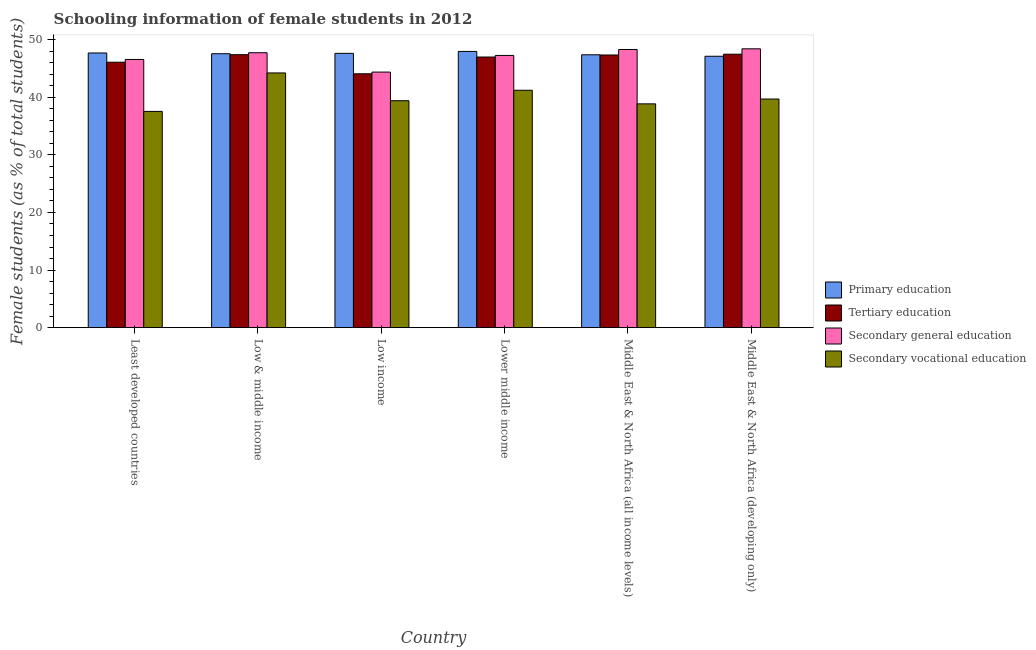How many groups of bars are there?
Your answer should be compact. 6. Are the number of bars per tick equal to the number of legend labels?
Make the answer very short. Yes. Are the number of bars on each tick of the X-axis equal?
Give a very brief answer. Yes. How many bars are there on the 5th tick from the left?
Your answer should be compact. 4. How many bars are there on the 1st tick from the right?
Offer a very short reply. 4. What is the label of the 6th group of bars from the left?
Your answer should be compact. Middle East & North Africa (developing only). What is the percentage of female students in primary education in Middle East & North Africa (developing only)?
Offer a very short reply. 47.12. Across all countries, what is the maximum percentage of female students in primary education?
Your answer should be very brief. 47.95. Across all countries, what is the minimum percentage of female students in tertiary education?
Offer a terse response. 44.07. In which country was the percentage of female students in primary education maximum?
Offer a very short reply. Lower middle income. What is the total percentage of female students in secondary vocational education in the graph?
Provide a short and direct response. 240.92. What is the difference between the percentage of female students in primary education in Least developed countries and that in Lower middle income?
Provide a short and direct response. -0.27. What is the difference between the percentage of female students in secondary vocational education in Lower middle income and the percentage of female students in tertiary education in Middle East & North Africa (developing only)?
Ensure brevity in your answer.  -6.26. What is the average percentage of female students in primary education per country?
Your response must be concise. 47.55. What is the difference between the percentage of female students in primary education and percentage of female students in tertiary education in Low & middle income?
Ensure brevity in your answer.  0.16. What is the ratio of the percentage of female students in secondary vocational education in Least developed countries to that in Low income?
Keep it short and to the point. 0.95. What is the difference between the highest and the second highest percentage of female students in secondary vocational education?
Provide a short and direct response. 3.01. What is the difference between the highest and the lowest percentage of female students in tertiary education?
Your response must be concise. 3.4. In how many countries, is the percentage of female students in tertiary education greater than the average percentage of female students in tertiary education taken over all countries?
Your answer should be very brief. 4. Is the sum of the percentage of female students in tertiary education in Lower middle income and Middle East & North Africa (developing only) greater than the maximum percentage of female students in secondary education across all countries?
Your answer should be very brief. Yes. What does the 1st bar from the left in Lower middle income represents?
Offer a terse response. Primary education. What does the 2nd bar from the right in Middle East & North Africa (developing only) represents?
Your answer should be very brief. Secondary general education. Is it the case that in every country, the sum of the percentage of female students in primary education and percentage of female students in tertiary education is greater than the percentage of female students in secondary education?
Your answer should be very brief. Yes. What is the difference between two consecutive major ticks on the Y-axis?
Your answer should be very brief. 10. Does the graph contain any zero values?
Your response must be concise. No. How many legend labels are there?
Keep it short and to the point. 4. How are the legend labels stacked?
Provide a succinct answer. Vertical. What is the title of the graph?
Provide a short and direct response. Schooling information of female students in 2012. What is the label or title of the X-axis?
Ensure brevity in your answer.  Country. What is the label or title of the Y-axis?
Make the answer very short. Female students (as % of total students). What is the Female students (as % of total students) in Primary education in Least developed countries?
Offer a terse response. 47.69. What is the Female students (as % of total students) in Tertiary education in Least developed countries?
Give a very brief answer. 46.08. What is the Female students (as % of total students) of Secondary general education in Least developed countries?
Your response must be concise. 46.56. What is the Female students (as % of total students) of Secondary vocational education in Least developed countries?
Ensure brevity in your answer.  37.54. What is the Female students (as % of total students) in Primary education in Low & middle income?
Ensure brevity in your answer.  47.56. What is the Female students (as % of total students) of Tertiary education in Low & middle income?
Make the answer very short. 47.39. What is the Female students (as % of total students) of Secondary general education in Low & middle income?
Keep it short and to the point. 47.73. What is the Female students (as % of total students) in Secondary vocational education in Low & middle income?
Make the answer very short. 44.22. What is the Female students (as % of total students) of Primary education in Low income?
Your response must be concise. 47.62. What is the Female students (as % of total students) of Tertiary education in Low income?
Keep it short and to the point. 44.07. What is the Female students (as % of total students) of Secondary general education in Low income?
Offer a terse response. 44.37. What is the Female students (as % of total students) of Secondary vocational education in Low income?
Provide a short and direct response. 39.4. What is the Female students (as % of total students) of Primary education in Lower middle income?
Offer a terse response. 47.95. What is the Female students (as % of total students) of Tertiary education in Lower middle income?
Offer a terse response. 46.98. What is the Female students (as % of total students) in Secondary general education in Lower middle income?
Ensure brevity in your answer.  47.26. What is the Female students (as % of total students) in Secondary vocational education in Lower middle income?
Give a very brief answer. 41.21. What is the Female students (as % of total students) of Primary education in Middle East & North Africa (all income levels)?
Give a very brief answer. 47.37. What is the Female students (as % of total students) of Tertiary education in Middle East & North Africa (all income levels)?
Provide a short and direct response. 47.34. What is the Female students (as % of total students) in Secondary general education in Middle East & North Africa (all income levels)?
Offer a very short reply. 48.29. What is the Female students (as % of total students) in Secondary vocational education in Middle East & North Africa (all income levels)?
Give a very brief answer. 38.85. What is the Female students (as % of total students) of Primary education in Middle East & North Africa (developing only)?
Offer a terse response. 47.12. What is the Female students (as % of total students) of Tertiary education in Middle East & North Africa (developing only)?
Give a very brief answer. 47.47. What is the Female students (as % of total students) in Secondary general education in Middle East & North Africa (developing only)?
Make the answer very short. 48.41. What is the Female students (as % of total students) of Secondary vocational education in Middle East & North Africa (developing only)?
Keep it short and to the point. 39.69. Across all countries, what is the maximum Female students (as % of total students) of Primary education?
Provide a short and direct response. 47.95. Across all countries, what is the maximum Female students (as % of total students) in Tertiary education?
Keep it short and to the point. 47.47. Across all countries, what is the maximum Female students (as % of total students) in Secondary general education?
Your answer should be very brief. 48.41. Across all countries, what is the maximum Female students (as % of total students) in Secondary vocational education?
Offer a terse response. 44.22. Across all countries, what is the minimum Female students (as % of total students) of Primary education?
Make the answer very short. 47.12. Across all countries, what is the minimum Female students (as % of total students) in Tertiary education?
Your answer should be very brief. 44.07. Across all countries, what is the minimum Female students (as % of total students) in Secondary general education?
Provide a short and direct response. 44.37. Across all countries, what is the minimum Female students (as % of total students) of Secondary vocational education?
Your response must be concise. 37.54. What is the total Female students (as % of total students) of Primary education in the graph?
Offer a terse response. 285.3. What is the total Female students (as % of total students) of Tertiary education in the graph?
Offer a terse response. 279.33. What is the total Female students (as % of total students) of Secondary general education in the graph?
Provide a short and direct response. 282.61. What is the total Female students (as % of total students) of Secondary vocational education in the graph?
Ensure brevity in your answer.  240.92. What is the difference between the Female students (as % of total students) of Primary education in Least developed countries and that in Low & middle income?
Offer a terse response. 0.13. What is the difference between the Female students (as % of total students) of Tertiary education in Least developed countries and that in Low & middle income?
Provide a succinct answer. -1.31. What is the difference between the Female students (as % of total students) in Secondary general education in Least developed countries and that in Low & middle income?
Give a very brief answer. -1.17. What is the difference between the Female students (as % of total students) of Secondary vocational education in Least developed countries and that in Low & middle income?
Make the answer very short. -6.68. What is the difference between the Female students (as % of total students) of Primary education in Least developed countries and that in Low income?
Your response must be concise. 0.06. What is the difference between the Female students (as % of total students) of Tertiary education in Least developed countries and that in Low income?
Provide a succinct answer. 2.01. What is the difference between the Female students (as % of total students) of Secondary general education in Least developed countries and that in Low income?
Offer a very short reply. 2.19. What is the difference between the Female students (as % of total students) in Secondary vocational education in Least developed countries and that in Low income?
Provide a succinct answer. -1.86. What is the difference between the Female students (as % of total students) of Primary education in Least developed countries and that in Lower middle income?
Ensure brevity in your answer.  -0.27. What is the difference between the Female students (as % of total students) of Tertiary education in Least developed countries and that in Lower middle income?
Your answer should be compact. -0.91. What is the difference between the Female students (as % of total students) in Secondary general education in Least developed countries and that in Lower middle income?
Your answer should be compact. -0.7. What is the difference between the Female students (as % of total students) of Secondary vocational education in Least developed countries and that in Lower middle income?
Make the answer very short. -3.67. What is the difference between the Female students (as % of total students) of Primary education in Least developed countries and that in Middle East & North Africa (all income levels)?
Ensure brevity in your answer.  0.31. What is the difference between the Female students (as % of total students) in Tertiary education in Least developed countries and that in Middle East & North Africa (all income levels)?
Provide a succinct answer. -1.26. What is the difference between the Female students (as % of total students) in Secondary general education in Least developed countries and that in Middle East & North Africa (all income levels)?
Make the answer very short. -1.73. What is the difference between the Female students (as % of total students) in Secondary vocational education in Least developed countries and that in Middle East & North Africa (all income levels)?
Offer a very short reply. -1.31. What is the difference between the Female students (as % of total students) of Primary education in Least developed countries and that in Middle East & North Africa (developing only)?
Provide a short and direct response. 0.57. What is the difference between the Female students (as % of total students) of Tertiary education in Least developed countries and that in Middle East & North Africa (developing only)?
Provide a short and direct response. -1.39. What is the difference between the Female students (as % of total students) in Secondary general education in Least developed countries and that in Middle East & North Africa (developing only)?
Keep it short and to the point. -1.85. What is the difference between the Female students (as % of total students) of Secondary vocational education in Least developed countries and that in Middle East & North Africa (developing only)?
Offer a terse response. -2.15. What is the difference between the Female students (as % of total students) in Primary education in Low & middle income and that in Low income?
Provide a succinct answer. -0.07. What is the difference between the Female students (as % of total students) of Tertiary education in Low & middle income and that in Low income?
Your answer should be compact. 3.32. What is the difference between the Female students (as % of total students) in Secondary general education in Low & middle income and that in Low income?
Your answer should be compact. 3.36. What is the difference between the Female students (as % of total students) in Secondary vocational education in Low & middle income and that in Low income?
Your response must be concise. 4.82. What is the difference between the Female students (as % of total students) of Primary education in Low & middle income and that in Lower middle income?
Give a very brief answer. -0.4. What is the difference between the Female students (as % of total students) in Tertiary education in Low & middle income and that in Lower middle income?
Your response must be concise. 0.41. What is the difference between the Female students (as % of total students) of Secondary general education in Low & middle income and that in Lower middle income?
Keep it short and to the point. 0.47. What is the difference between the Female students (as % of total students) in Secondary vocational education in Low & middle income and that in Lower middle income?
Offer a terse response. 3.01. What is the difference between the Female students (as % of total students) of Primary education in Low & middle income and that in Middle East & North Africa (all income levels)?
Keep it short and to the point. 0.18. What is the difference between the Female students (as % of total students) of Tertiary education in Low & middle income and that in Middle East & North Africa (all income levels)?
Your answer should be very brief. 0.05. What is the difference between the Female students (as % of total students) in Secondary general education in Low & middle income and that in Middle East & North Africa (all income levels)?
Your response must be concise. -0.56. What is the difference between the Female students (as % of total students) in Secondary vocational education in Low & middle income and that in Middle East & North Africa (all income levels)?
Ensure brevity in your answer.  5.37. What is the difference between the Female students (as % of total students) in Primary education in Low & middle income and that in Middle East & North Africa (developing only)?
Ensure brevity in your answer.  0.44. What is the difference between the Female students (as % of total students) in Tertiary education in Low & middle income and that in Middle East & North Africa (developing only)?
Keep it short and to the point. -0.08. What is the difference between the Female students (as % of total students) in Secondary general education in Low & middle income and that in Middle East & North Africa (developing only)?
Provide a succinct answer. -0.68. What is the difference between the Female students (as % of total students) of Secondary vocational education in Low & middle income and that in Middle East & North Africa (developing only)?
Offer a terse response. 4.53. What is the difference between the Female students (as % of total students) in Primary education in Low income and that in Lower middle income?
Your response must be concise. -0.33. What is the difference between the Female students (as % of total students) of Tertiary education in Low income and that in Lower middle income?
Give a very brief answer. -2.91. What is the difference between the Female students (as % of total students) in Secondary general education in Low income and that in Lower middle income?
Your answer should be compact. -2.89. What is the difference between the Female students (as % of total students) of Secondary vocational education in Low income and that in Lower middle income?
Offer a very short reply. -1.81. What is the difference between the Female students (as % of total students) of Primary education in Low income and that in Middle East & North Africa (all income levels)?
Keep it short and to the point. 0.25. What is the difference between the Female students (as % of total students) of Tertiary education in Low income and that in Middle East & North Africa (all income levels)?
Your answer should be very brief. -3.26. What is the difference between the Female students (as % of total students) in Secondary general education in Low income and that in Middle East & North Africa (all income levels)?
Your answer should be compact. -3.92. What is the difference between the Female students (as % of total students) in Secondary vocational education in Low income and that in Middle East & North Africa (all income levels)?
Offer a very short reply. 0.55. What is the difference between the Female students (as % of total students) of Primary education in Low income and that in Middle East & North Africa (developing only)?
Your answer should be compact. 0.51. What is the difference between the Female students (as % of total students) in Tertiary education in Low income and that in Middle East & North Africa (developing only)?
Provide a short and direct response. -3.4. What is the difference between the Female students (as % of total students) in Secondary general education in Low income and that in Middle East & North Africa (developing only)?
Offer a terse response. -4.04. What is the difference between the Female students (as % of total students) of Secondary vocational education in Low income and that in Middle East & North Africa (developing only)?
Your response must be concise. -0.29. What is the difference between the Female students (as % of total students) of Primary education in Lower middle income and that in Middle East & North Africa (all income levels)?
Ensure brevity in your answer.  0.58. What is the difference between the Female students (as % of total students) of Tertiary education in Lower middle income and that in Middle East & North Africa (all income levels)?
Your response must be concise. -0.35. What is the difference between the Female students (as % of total students) of Secondary general education in Lower middle income and that in Middle East & North Africa (all income levels)?
Your answer should be very brief. -1.03. What is the difference between the Female students (as % of total students) in Secondary vocational education in Lower middle income and that in Middle East & North Africa (all income levels)?
Your answer should be very brief. 2.36. What is the difference between the Female students (as % of total students) in Primary education in Lower middle income and that in Middle East & North Africa (developing only)?
Provide a succinct answer. 0.84. What is the difference between the Female students (as % of total students) in Tertiary education in Lower middle income and that in Middle East & North Africa (developing only)?
Your answer should be compact. -0.49. What is the difference between the Female students (as % of total students) in Secondary general education in Lower middle income and that in Middle East & North Africa (developing only)?
Your response must be concise. -1.15. What is the difference between the Female students (as % of total students) in Secondary vocational education in Lower middle income and that in Middle East & North Africa (developing only)?
Your answer should be very brief. 1.52. What is the difference between the Female students (as % of total students) in Primary education in Middle East & North Africa (all income levels) and that in Middle East & North Africa (developing only)?
Make the answer very short. 0.25. What is the difference between the Female students (as % of total students) in Tertiary education in Middle East & North Africa (all income levels) and that in Middle East & North Africa (developing only)?
Provide a succinct answer. -0.14. What is the difference between the Female students (as % of total students) in Secondary general education in Middle East & North Africa (all income levels) and that in Middle East & North Africa (developing only)?
Offer a terse response. -0.12. What is the difference between the Female students (as % of total students) of Secondary vocational education in Middle East & North Africa (all income levels) and that in Middle East & North Africa (developing only)?
Your answer should be very brief. -0.84. What is the difference between the Female students (as % of total students) in Primary education in Least developed countries and the Female students (as % of total students) in Tertiary education in Low & middle income?
Keep it short and to the point. 0.29. What is the difference between the Female students (as % of total students) of Primary education in Least developed countries and the Female students (as % of total students) of Secondary general education in Low & middle income?
Provide a succinct answer. -0.04. What is the difference between the Female students (as % of total students) in Primary education in Least developed countries and the Female students (as % of total students) in Secondary vocational education in Low & middle income?
Offer a terse response. 3.47. What is the difference between the Female students (as % of total students) in Tertiary education in Least developed countries and the Female students (as % of total students) in Secondary general education in Low & middle income?
Your answer should be compact. -1.65. What is the difference between the Female students (as % of total students) in Tertiary education in Least developed countries and the Female students (as % of total students) in Secondary vocational education in Low & middle income?
Offer a very short reply. 1.86. What is the difference between the Female students (as % of total students) of Secondary general education in Least developed countries and the Female students (as % of total students) of Secondary vocational education in Low & middle income?
Make the answer very short. 2.34. What is the difference between the Female students (as % of total students) in Primary education in Least developed countries and the Female students (as % of total students) in Tertiary education in Low income?
Your answer should be very brief. 3.61. What is the difference between the Female students (as % of total students) of Primary education in Least developed countries and the Female students (as % of total students) of Secondary general education in Low income?
Your answer should be compact. 3.32. What is the difference between the Female students (as % of total students) of Primary education in Least developed countries and the Female students (as % of total students) of Secondary vocational education in Low income?
Give a very brief answer. 8.29. What is the difference between the Female students (as % of total students) of Tertiary education in Least developed countries and the Female students (as % of total students) of Secondary general education in Low income?
Give a very brief answer. 1.71. What is the difference between the Female students (as % of total students) of Tertiary education in Least developed countries and the Female students (as % of total students) of Secondary vocational education in Low income?
Offer a very short reply. 6.68. What is the difference between the Female students (as % of total students) of Secondary general education in Least developed countries and the Female students (as % of total students) of Secondary vocational education in Low income?
Provide a short and direct response. 7.16. What is the difference between the Female students (as % of total students) of Primary education in Least developed countries and the Female students (as % of total students) of Tertiary education in Lower middle income?
Ensure brevity in your answer.  0.7. What is the difference between the Female students (as % of total students) of Primary education in Least developed countries and the Female students (as % of total students) of Secondary general education in Lower middle income?
Provide a short and direct response. 0.43. What is the difference between the Female students (as % of total students) of Primary education in Least developed countries and the Female students (as % of total students) of Secondary vocational education in Lower middle income?
Your answer should be very brief. 6.47. What is the difference between the Female students (as % of total students) in Tertiary education in Least developed countries and the Female students (as % of total students) in Secondary general education in Lower middle income?
Your answer should be very brief. -1.18. What is the difference between the Female students (as % of total students) of Tertiary education in Least developed countries and the Female students (as % of total students) of Secondary vocational education in Lower middle income?
Provide a short and direct response. 4.87. What is the difference between the Female students (as % of total students) in Secondary general education in Least developed countries and the Female students (as % of total students) in Secondary vocational education in Lower middle income?
Give a very brief answer. 5.35. What is the difference between the Female students (as % of total students) in Primary education in Least developed countries and the Female students (as % of total students) in Tertiary education in Middle East & North Africa (all income levels)?
Your response must be concise. 0.35. What is the difference between the Female students (as % of total students) of Primary education in Least developed countries and the Female students (as % of total students) of Secondary general education in Middle East & North Africa (all income levels)?
Your answer should be very brief. -0.61. What is the difference between the Female students (as % of total students) of Primary education in Least developed countries and the Female students (as % of total students) of Secondary vocational education in Middle East & North Africa (all income levels)?
Make the answer very short. 8.83. What is the difference between the Female students (as % of total students) of Tertiary education in Least developed countries and the Female students (as % of total students) of Secondary general education in Middle East & North Africa (all income levels)?
Make the answer very short. -2.21. What is the difference between the Female students (as % of total students) in Tertiary education in Least developed countries and the Female students (as % of total students) in Secondary vocational education in Middle East & North Africa (all income levels)?
Keep it short and to the point. 7.23. What is the difference between the Female students (as % of total students) in Secondary general education in Least developed countries and the Female students (as % of total students) in Secondary vocational education in Middle East & North Africa (all income levels)?
Make the answer very short. 7.71. What is the difference between the Female students (as % of total students) in Primary education in Least developed countries and the Female students (as % of total students) in Tertiary education in Middle East & North Africa (developing only)?
Ensure brevity in your answer.  0.21. What is the difference between the Female students (as % of total students) in Primary education in Least developed countries and the Female students (as % of total students) in Secondary general education in Middle East & North Africa (developing only)?
Ensure brevity in your answer.  -0.72. What is the difference between the Female students (as % of total students) in Primary education in Least developed countries and the Female students (as % of total students) in Secondary vocational education in Middle East & North Africa (developing only)?
Ensure brevity in your answer.  7.99. What is the difference between the Female students (as % of total students) in Tertiary education in Least developed countries and the Female students (as % of total students) in Secondary general education in Middle East & North Africa (developing only)?
Offer a terse response. -2.33. What is the difference between the Female students (as % of total students) of Tertiary education in Least developed countries and the Female students (as % of total students) of Secondary vocational education in Middle East & North Africa (developing only)?
Your answer should be very brief. 6.39. What is the difference between the Female students (as % of total students) in Secondary general education in Least developed countries and the Female students (as % of total students) in Secondary vocational education in Middle East & North Africa (developing only)?
Keep it short and to the point. 6.87. What is the difference between the Female students (as % of total students) of Primary education in Low & middle income and the Female students (as % of total students) of Tertiary education in Low income?
Your response must be concise. 3.48. What is the difference between the Female students (as % of total students) in Primary education in Low & middle income and the Female students (as % of total students) in Secondary general education in Low income?
Make the answer very short. 3.19. What is the difference between the Female students (as % of total students) in Primary education in Low & middle income and the Female students (as % of total students) in Secondary vocational education in Low income?
Offer a very short reply. 8.16. What is the difference between the Female students (as % of total students) in Tertiary education in Low & middle income and the Female students (as % of total students) in Secondary general education in Low income?
Provide a short and direct response. 3.02. What is the difference between the Female students (as % of total students) in Tertiary education in Low & middle income and the Female students (as % of total students) in Secondary vocational education in Low income?
Give a very brief answer. 7.99. What is the difference between the Female students (as % of total students) in Secondary general education in Low & middle income and the Female students (as % of total students) in Secondary vocational education in Low income?
Offer a terse response. 8.33. What is the difference between the Female students (as % of total students) in Primary education in Low & middle income and the Female students (as % of total students) in Tertiary education in Lower middle income?
Keep it short and to the point. 0.57. What is the difference between the Female students (as % of total students) in Primary education in Low & middle income and the Female students (as % of total students) in Secondary general education in Lower middle income?
Offer a terse response. 0.3. What is the difference between the Female students (as % of total students) of Primary education in Low & middle income and the Female students (as % of total students) of Secondary vocational education in Lower middle income?
Make the answer very short. 6.34. What is the difference between the Female students (as % of total students) of Tertiary education in Low & middle income and the Female students (as % of total students) of Secondary general education in Lower middle income?
Keep it short and to the point. 0.13. What is the difference between the Female students (as % of total students) of Tertiary education in Low & middle income and the Female students (as % of total students) of Secondary vocational education in Lower middle income?
Your answer should be compact. 6.18. What is the difference between the Female students (as % of total students) of Secondary general education in Low & middle income and the Female students (as % of total students) of Secondary vocational education in Lower middle income?
Offer a very short reply. 6.52. What is the difference between the Female students (as % of total students) of Primary education in Low & middle income and the Female students (as % of total students) of Tertiary education in Middle East & North Africa (all income levels)?
Make the answer very short. 0.22. What is the difference between the Female students (as % of total students) of Primary education in Low & middle income and the Female students (as % of total students) of Secondary general education in Middle East & North Africa (all income levels)?
Your answer should be compact. -0.74. What is the difference between the Female students (as % of total students) of Primary education in Low & middle income and the Female students (as % of total students) of Secondary vocational education in Middle East & North Africa (all income levels)?
Provide a short and direct response. 8.7. What is the difference between the Female students (as % of total students) in Tertiary education in Low & middle income and the Female students (as % of total students) in Secondary general education in Middle East & North Africa (all income levels)?
Keep it short and to the point. -0.9. What is the difference between the Female students (as % of total students) in Tertiary education in Low & middle income and the Female students (as % of total students) in Secondary vocational education in Middle East & North Africa (all income levels)?
Make the answer very short. 8.54. What is the difference between the Female students (as % of total students) in Secondary general education in Low & middle income and the Female students (as % of total students) in Secondary vocational education in Middle East & North Africa (all income levels)?
Ensure brevity in your answer.  8.88. What is the difference between the Female students (as % of total students) of Primary education in Low & middle income and the Female students (as % of total students) of Tertiary education in Middle East & North Africa (developing only)?
Your answer should be very brief. 0.08. What is the difference between the Female students (as % of total students) of Primary education in Low & middle income and the Female students (as % of total students) of Secondary general education in Middle East & North Africa (developing only)?
Offer a terse response. -0.85. What is the difference between the Female students (as % of total students) of Primary education in Low & middle income and the Female students (as % of total students) of Secondary vocational education in Middle East & North Africa (developing only)?
Offer a terse response. 7.86. What is the difference between the Female students (as % of total students) of Tertiary education in Low & middle income and the Female students (as % of total students) of Secondary general education in Middle East & North Africa (developing only)?
Ensure brevity in your answer.  -1.02. What is the difference between the Female students (as % of total students) of Tertiary education in Low & middle income and the Female students (as % of total students) of Secondary vocational education in Middle East & North Africa (developing only)?
Ensure brevity in your answer.  7.7. What is the difference between the Female students (as % of total students) in Secondary general education in Low & middle income and the Female students (as % of total students) in Secondary vocational education in Middle East & North Africa (developing only)?
Give a very brief answer. 8.04. What is the difference between the Female students (as % of total students) in Primary education in Low income and the Female students (as % of total students) in Tertiary education in Lower middle income?
Keep it short and to the point. 0.64. What is the difference between the Female students (as % of total students) in Primary education in Low income and the Female students (as % of total students) in Secondary general education in Lower middle income?
Your response must be concise. 0.36. What is the difference between the Female students (as % of total students) in Primary education in Low income and the Female students (as % of total students) in Secondary vocational education in Lower middle income?
Make the answer very short. 6.41. What is the difference between the Female students (as % of total students) of Tertiary education in Low income and the Female students (as % of total students) of Secondary general education in Lower middle income?
Your answer should be compact. -3.19. What is the difference between the Female students (as % of total students) in Tertiary education in Low income and the Female students (as % of total students) in Secondary vocational education in Lower middle income?
Offer a very short reply. 2.86. What is the difference between the Female students (as % of total students) of Secondary general education in Low income and the Female students (as % of total students) of Secondary vocational education in Lower middle income?
Your response must be concise. 3.15. What is the difference between the Female students (as % of total students) of Primary education in Low income and the Female students (as % of total students) of Tertiary education in Middle East & North Africa (all income levels)?
Offer a very short reply. 0.29. What is the difference between the Female students (as % of total students) in Primary education in Low income and the Female students (as % of total students) in Secondary general education in Middle East & North Africa (all income levels)?
Provide a short and direct response. -0.67. What is the difference between the Female students (as % of total students) of Primary education in Low income and the Female students (as % of total students) of Secondary vocational education in Middle East & North Africa (all income levels)?
Your answer should be compact. 8.77. What is the difference between the Female students (as % of total students) in Tertiary education in Low income and the Female students (as % of total students) in Secondary general education in Middle East & North Africa (all income levels)?
Offer a very short reply. -4.22. What is the difference between the Female students (as % of total students) in Tertiary education in Low income and the Female students (as % of total students) in Secondary vocational education in Middle East & North Africa (all income levels)?
Your response must be concise. 5.22. What is the difference between the Female students (as % of total students) of Secondary general education in Low income and the Female students (as % of total students) of Secondary vocational education in Middle East & North Africa (all income levels)?
Your answer should be compact. 5.51. What is the difference between the Female students (as % of total students) of Primary education in Low income and the Female students (as % of total students) of Tertiary education in Middle East & North Africa (developing only)?
Ensure brevity in your answer.  0.15. What is the difference between the Female students (as % of total students) of Primary education in Low income and the Female students (as % of total students) of Secondary general education in Middle East & North Africa (developing only)?
Provide a succinct answer. -0.79. What is the difference between the Female students (as % of total students) in Primary education in Low income and the Female students (as % of total students) in Secondary vocational education in Middle East & North Africa (developing only)?
Provide a succinct answer. 7.93. What is the difference between the Female students (as % of total students) of Tertiary education in Low income and the Female students (as % of total students) of Secondary general education in Middle East & North Africa (developing only)?
Keep it short and to the point. -4.34. What is the difference between the Female students (as % of total students) in Tertiary education in Low income and the Female students (as % of total students) in Secondary vocational education in Middle East & North Africa (developing only)?
Give a very brief answer. 4.38. What is the difference between the Female students (as % of total students) of Secondary general education in Low income and the Female students (as % of total students) of Secondary vocational education in Middle East & North Africa (developing only)?
Provide a succinct answer. 4.68. What is the difference between the Female students (as % of total students) of Primary education in Lower middle income and the Female students (as % of total students) of Tertiary education in Middle East & North Africa (all income levels)?
Provide a short and direct response. 0.62. What is the difference between the Female students (as % of total students) in Primary education in Lower middle income and the Female students (as % of total students) in Secondary general education in Middle East & North Africa (all income levels)?
Offer a terse response. -0.34. What is the difference between the Female students (as % of total students) in Primary education in Lower middle income and the Female students (as % of total students) in Secondary vocational education in Middle East & North Africa (all income levels)?
Offer a terse response. 9.1. What is the difference between the Female students (as % of total students) of Tertiary education in Lower middle income and the Female students (as % of total students) of Secondary general education in Middle East & North Africa (all income levels)?
Provide a succinct answer. -1.31. What is the difference between the Female students (as % of total students) in Tertiary education in Lower middle income and the Female students (as % of total students) in Secondary vocational education in Middle East & North Africa (all income levels)?
Offer a very short reply. 8.13. What is the difference between the Female students (as % of total students) in Secondary general education in Lower middle income and the Female students (as % of total students) in Secondary vocational education in Middle East & North Africa (all income levels)?
Your answer should be very brief. 8.41. What is the difference between the Female students (as % of total students) in Primary education in Lower middle income and the Female students (as % of total students) in Tertiary education in Middle East & North Africa (developing only)?
Your answer should be compact. 0.48. What is the difference between the Female students (as % of total students) of Primary education in Lower middle income and the Female students (as % of total students) of Secondary general education in Middle East & North Africa (developing only)?
Your response must be concise. -0.45. What is the difference between the Female students (as % of total students) of Primary education in Lower middle income and the Female students (as % of total students) of Secondary vocational education in Middle East & North Africa (developing only)?
Your response must be concise. 8.26. What is the difference between the Female students (as % of total students) in Tertiary education in Lower middle income and the Female students (as % of total students) in Secondary general education in Middle East & North Africa (developing only)?
Your response must be concise. -1.42. What is the difference between the Female students (as % of total students) in Tertiary education in Lower middle income and the Female students (as % of total students) in Secondary vocational education in Middle East & North Africa (developing only)?
Ensure brevity in your answer.  7.29. What is the difference between the Female students (as % of total students) in Secondary general education in Lower middle income and the Female students (as % of total students) in Secondary vocational education in Middle East & North Africa (developing only)?
Make the answer very short. 7.57. What is the difference between the Female students (as % of total students) of Primary education in Middle East & North Africa (all income levels) and the Female students (as % of total students) of Tertiary education in Middle East & North Africa (developing only)?
Your answer should be compact. -0.1. What is the difference between the Female students (as % of total students) of Primary education in Middle East & North Africa (all income levels) and the Female students (as % of total students) of Secondary general education in Middle East & North Africa (developing only)?
Ensure brevity in your answer.  -1.04. What is the difference between the Female students (as % of total students) of Primary education in Middle East & North Africa (all income levels) and the Female students (as % of total students) of Secondary vocational education in Middle East & North Africa (developing only)?
Ensure brevity in your answer.  7.68. What is the difference between the Female students (as % of total students) in Tertiary education in Middle East & North Africa (all income levels) and the Female students (as % of total students) in Secondary general education in Middle East & North Africa (developing only)?
Your answer should be very brief. -1.07. What is the difference between the Female students (as % of total students) of Tertiary education in Middle East & North Africa (all income levels) and the Female students (as % of total students) of Secondary vocational education in Middle East & North Africa (developing only)?
Provide a succinct answer. 7.65. What is the difference between the Female students (as % of total students) in Secondary general education in Middle East & North Africa (all income levels) and the Female students (as % of total students) in Secondary vocational education in Middle East & North Africa (developing only)?
Provide a short and direct response. 8.6. What is the average Female students (as % of total students) of Primary education per country?
Provide a short and direct response. 47.55. What is the average Female students (as % of total students) of Tertiary education per country?
Offer a very short reply. 46.56. What is the average Female students (as % of total students) of Secondary general education per country?
Your answer should be compact. 47.1. What is the average Female students (as % of total students) in Secondary vocational education per country?
Provide a succinct answer. 40.15. What is the difference between the Female students (as % of total students) of Primary education and Female students (as % of total students) of Tertiary education in Least developed countries?
Provide a short and direct response. 1.61. What is the difference between the Female students (as % of total students) of Primary education and Female students (as % of total students) of Secondary general education in Least developed countries?
Make the answer very short. 1.13. What is the difference between the Female students (as % of total students) of Primary education and Female students (as % of total students) of Secondary vocational education in Least developed countries?
Your response must be concise. 10.14. What is the difference between the Female students (as % of total students) of Tertiary education and Female students (as % of total students) of Secondary general education in Least developed countries?
Offer a very short reply. -0.48. What is the difference between the Female students (as % of total students) in Tertiary education and Female students (as % of total students) in Secondary vocational education in Least developed countries?
Your answer should be very brief. 8.54. What is the difference between the Female students (as % of total students) of Secondary general education and Female students (as % of total students) of Secondary vocational education in Least developed countries?
Provide a succinct answer. 9.02. What is the difference between the Female students (as % of total students) in Primary education and Female students (as % of total students) in Tertiary education in Low & middle income?
Give a very brief answer. 0.16. What is the difference between the Female students (as % of total students) of Primary education and Female students (as % of total students) of Secondary general education in Low & middle income?
Offer a terse response. -0.17. What is the difference between the Female students (as % of total students) of Primary education and Female students (as % of total students) of Secondary vocational education in Low & middle income?
Provide a succinct answer. 3.34. What is the difference between the Female students (as % of total students) in Tertiary education and Female students (as % of total students) in Secondary general education in Low & middle income?
Provide a short and direct response. -0.34. What is the difference between the Female students (as % of total students) in Tertiary education and Female students (as % of total students) in Secondary vocational education in Low & middle income?
Provide a short and direct response. 3.17. What is the difference between the Female students (as % of total students) of Secondary general education and Female students (as % of total students) of Secondary vocational education in Low & middle income?
Offer a very short reply. 3.51. What is the difference between the Female students (as % of total students) in Primary education and Female students (as % of total students) in Tertiary education in Low income?
Your answer should be very brief. 3.55. What is the difference between the Female students (as % of total students) in Primary education and Female students (as % of total students) in Secondary general education in Low income?
Provide a succinct answer. 3.25. What is the difference between the Female students (as % of total students) of Primary education and Female students (as % of total students) of Secondary vocational education in Low income?
Provide a succinct answer. 8.22. What is the difference between the Female students (as % of total students) in Tertiary education and Female students (as % of total students) in Secondary general education in Low income?
Keep it short and to the point. -0.3. What is the difference between the Female students (as % of total students) of Tertiary education and Female students (as % of total students) of Secondary vocational education in Low income?
Provide a succinct answer. 4.67. What is the difference between the Female students (as % of total students) of Secondary general education and Female students (as % of total students) of Secondary vocational education in Low income?
Provide a succinct answer. 4.97. What is the difference between the Female students (as % of total students) of Primary education and Female students (as % of total students) of Tertiary education in Lower middle income?
Your response must be concise. 0.97. What is the difference between the Female students (as % of total students) of Primary education and Female students (as % of total students) of Secondary general education in Lower middle income?
Your answer should be very brief. 0.69. What is the difference between the Female students (as % of total students) of Primary education and Female students (as % of total students) of Secondary vocational education in Lower middle income?
Make the answer very short. 6.74. What is the difference between the Female students (as % of total students) of Tertiary education and Female students (as % of total students) of Secondary general education in Lower middle income?
Keep it short and to the point. -0.28. What is the difference between the Female students (as % of total students) in Tertiary education and Female students (as % of total students) in Secondary vocational education in Lower middle income?
Provide a succinct answer. 5.77. What is the difference between the Female students (as % of total students) of Secondary general education and Female students (as % of total students) of Secondary vocational education in Lower middle income?
Provide a succinct answer. 6.05. What is the difference between the Female students (as % of total students) in Primary education and Female students (as % of total students) in Tertiary education in Middle East & North Africa (all income levels)?
Provide a succinct answer. 0.03. What is the difference between the Female students (as % of total students) of Primary education and Female students (as % of total students) of Secondary general education in Middle East & North Africa (all income levels)?
Ensure brevity in your answer.  -0.92. What is the difference between the Female students (as % of total students) of Primary education and Female students (as % of total students) of Secondary vocational education in Middle East & North Africa (all income levels)?
Your answer should be compact. 8.52. What is the difference between the Female students (as % of total students) of Tertiary education and Female students (as % of total students) of Secondary general education in Middle East & North Africa (all income levels)?
Your answer should be compact. -0.96. What is the difference between the Female students (as % of total students) in Tertiary education and Female students (as % of total students) in Secondary vocational education in Middle East & North Africa (all income levels)?
Your answer should be very brief. 8.48. What is the difference between the Female students (as % of total students) in Secondary general education and Female students (as % of total students) in Secondary vocational education in Middle East & North Africa (all income levels)?
Your answer should be very brief. 9.44. What is the difference between the Female students (as % of total students) in Primary education and Female students (as % of total students) in Tertiary education in Middle East & North Africa (developing only)?
Keep it short and to the point. -0.36. What is the difference between the Female students (as % of total students) in Primary education and Female students (as % of total students) in Secondary general education in Middle East & North Africa (developing only)?
Offer a terse response. -1.29. What is the difference between the Female students (as % of total students) of Primary education and Female students (as % of total students) of Secondary vocational education in Middle East & North Africa (developing only)?
Provide a short and direct response. 7.43. What is the difference between the Female students (as % of total students) of Tertiary education and Female students (as % of total students) of Secondary general education in Middle East & North Africa (developing only)?
Your response must be concise. -0.94. What is the difference between the Female students (as % of total students) of Tertiary education and Female students (as % of total students) of Secondary vocational education in Middle East & North Africa (developing only)?
Ensure brevity in your answer.  7.78. What is the difference between the Female students (as % of total students) of Secondary general education and Female students (as % of total students) of Secondary vocational education in Middle East & North Africa (developing only)?
Make the answer very short. 8.72. What is the ratio of the Female students (as % of total students) in Tertiary education in Least developed countries to that in Low & middle income?
Provide a succinct answer. 0.97. What is the ratio of the Female students (as % of total students) of Secondary general education in Least developed countries to that in Low & middle income?
Your response must be concise. 0.98. What is the ratio of the Female students (as % of total students) of Secondary vocational education in Least developed countries to that in Low & middle income?
Make the answer very short. 0.85. What is the ratio of the Female students (as % of total students) in Tertiary education in Least developed countries to that in Low income?
Your answer should be very brief. 1.05. What is the ratio of the Female students (as % of total students) of Secondary general education in Least developed countries to that in Low income?
Make the answer very short. 1.05. What is the ratio of the Female students (as % of total students) in Secondary vocational education in Least developed countries to that in Low income?
Keep it short and to the point. 0.95. What is the ratio of the Female students (as % of total students) in Tertiary education in Least developed countries to that in Lower middle income?
Provide a short and direct response. 0.98. What is the ratio of the Female students (as % of total students) of Secondary general education in Least developed countries to that in Lower middle income?
Offer a terse response. 0.99. What is the ratio of the Female students (as % of total students) in Secondary vocational education in Least developed countries to that in Lower middle income?
Your answer should be compact. 0.91. What is the ratio of the Female students (as % of total students) in Primary education in Least developed countries to that in Middle East & North Africa (all income levels)?
Offer a very short reply. 1.01. What is the ratio of the Female students (as % of total students) of Tertiary education in Least developed countries to that in Middle East & North Africa (all income levels)?
Your answer should be very brief. 0.97. What is the ratio of the Female students (as % of total students) of Secondary general education in Least developed countries to that in Middle East & North Africa (all income levels)?
Keep it short and to the point. 0.96. What is the ratio of the Female students (as % of total students) in Secondary vocational education in Least developed countries to that in Middle East & North Africa (all income levels)?
Offer a very short reply. 0.97. What is the ratio of the Female students (as % of total students) of Primary education in Least developed countries to that in Middle East & North Africa (developing only)?
Offer a very short reply. 1.01. What is the ratio of the Female students (as % of total students) of Tertiary education in Least developed countries to that in Middle East & North Africa (developing only)?
Give a very brief answer. 0.97. What is the ratio of the Female students (as % of total students) in Secondary general education in Least developed countries to that in Middle East & North Africa (developing only)?
Offer a very short reply. 0.96. What is the ratio of the Female students (as % of total students) in Secondary vocational education in Least developed countries to that in Middle East & North Africa (developing only)?
Provide a succinct answer. 0.95. What is the ratio of the Female students (as % of total students) of Tertiary education in Low & middle income to that in Low income?
Give a very brief answer. 1.08. What is the ratio of the Female students (as % of total students) of Secondary general education in Low & middle income to that in Low income?
Offer a very short reply. 1.08. What is the ratio of the Female students (as % of total students) of Secondary vocational education in Low & middle income to that in Low income?
Offer a terse response. 1.12. What is the ratio of the Female students (as % of total students) of Primary education in Low & middle income to that in Lower middle income?
Keep it short and to the point. 0.99. What is the ratio of the Female students (as % of total students) in Tertiary education in Low & middle income to that in Lower middle income?
Your response must be concise. 1.01. What is the ratio of the Female students (as % of total students) in Secondary general education in Low & middle income to that in Lower middle income?
Your answer should be very brief. 1.01. What is the ratio of the Female students (as % of total students) in Secondary vocational education in Low & middle income to that in Lower middle income?
Provide a short and direct response. 1.07. What is the ratio of the Female students (as % of total students) in Tertiary education in Low & middle income to that in Middle East & North Africa (all income levels)?
Ensure brevity in your answer.  1. What is the ratio of the Female students (as % of total students) in Secondary general education in Low & middle income to that in Middle East & North Africa (all income levels)?
Your answer should be compact. 0.99. What is the ratio of the Female students (as % of total students) in Secondary vocational education in Low & middle income to that in Middle East & North Africa (all income levels)?
Make the answer very short. 1.14. What is the ratio of the Female students (as % of total students) in Primary education in Low & middle income to that in Middle East & North Africa (developing only)?
Your answer should be compact. 1.01. What is the ratio of the Female students (as % of total students) in Secondary vocational education in Low & middle income to that in Middle East & North Africa (developing only)?
Your response must be concise. 1.11. What is the ratio of the Female students (as % of total students) in Primary education in Low income to that in Lower middle income?
Your response must be concise. 0.99. What is the ratio of the Female students (as % of total students) of Tertiary education in Low income to that in Lower middle income?
Provide a short and direct response. 0.94. What is the ratio of the Female students (as % of total students) in Secondary general education in Low income to that in Lower middle income?
Make the answer very short. 0.94. What is the ratio of the Female students (as % of total students) of Secondary vocational education in Low income to that in Lower middle income?
Make the answer very short. 0.96. What is the ratio of the Female students (as % of total students) in Primary education in Low income to that in Middle East & North Africa (all income levels)?
Your answer should be compact. 1.01. What is the ratio of the Female students (as % of total students) in Secondary general education in Low income to that in Middle East & North Africa (all income levels)?
Make the answer very short. 0.92. What is the ratio of the Female students (as % of total students) in Secondary vocational education in Low income to that in Middle East & North Africa (all income levels)?
Make the answer very short. 1.01. What is the ratio of the Female students (as % of total students) of Primary education in Low income to that in Middle East & North Africa (developing only)?
Make the answer very short. 1.01. What is the ratio of the Female students (as % of total students) in Tertiary education in Low income to that in Middle East & North Africa (developing only)?
Provide a succinct answer. 0.93. What is the ratio of the Female students (as % of total students) of Secondary general education in Low income to that in Middle East & North Africa (developing only)?
Offer a very short reply. 0.92. What is the ratio of the Female students (as % of total students) of Primary education in Lower middle income to that in Middle East & North Africa (all income levels)?
Offer a terse response. 1.01. What is the ratio of the Female students (as % of total students) in Tertiary education in Lower middle income to that in Middle East & North Africa (all income levels)?
Ensure brevity in your answer.  0.99. What is the ratio of the Female students (as % of total students) in Secondary general education in Lower middle income to that in Middle East & North Africa (all income levels)?
Ensure brevity in your answer.  0.98. What is the ratio of the Female students (as % of total students) of Secondary vocational education in Lower middle income to that in Middle East & North Africa (all income levels)?
Offer a terse response. 1.06. What is the ratio of the Female students (as % of total students) in Primary education in Lower middle income to that in Middle East & North Africa (developing only)?
Make the answer very short. 1.02. What is the ratio of the Female students (as % of total students) of Tertiary education in Lower middle income to that in Middle East & North Africa (developing only)?
Provide a succinct answer. 0.99. What is the ratio of the Female students (as % of total students) of Secondary general education in Lower middle income to that in Middle East & North Africa (developing only)?
Offer a very short reply. 0.98. What is the ratio of the Female students (as % of total students) in Secondary vocational education in Lower middle income to that in Middle East & North Africa (developing only)?
Keep it short and to the point. 1.04. What is the ratio of the Female students (as % of total students) of Primary education in Middle East & North Africa (all income levels) to that in Middle East & North Africa (developing only)?
Keep it short and to the point. 1.01. What is the ratio of the Female students (as % of total students) of Tertiary education in Middle East & North Africa (all income levels) to that in Middle East & North Africa (developing only)?
Your response must be concise. 1. What is the ratio of the Female students (as % of total students) of Secondary general education in Middle East & North Africa (all income levels) to that in Middle East & North Africa (developing only)?
Make the answer very short. 1. What is the ratio of the Female students (as % of total students) of Secondary vocational education in Middle East & North Africa (all income levels) to that in Middle East & North Africa (developing only)?
Ensure brevity in your answer.  0.98. What is the difference between the highest and the second highest Female students (as % of total students) in Primary education?
Your answer should be very brief. 0.27. What is the difference between the highest and the second highest Female students (as % of total students) of Tertiary education?
Provide a short and direct response. 0.08. What is the difference between the highest and the second highest Female students (as % of total students) in Secondary general education?
Your answer should be compact. 0.12. What is the difference between the highest and the second highest Female students (as % of total students) in Secondary vocational education?
Your answer should be very brief. 3.01. What is the difference between the highest and the lowest Female students (as % of total students) in Primary education?
Your response must be concise. 0.84. What is the difference between the highest and the lowest Female students (as % of total students) of Tertiary education?
Your answer should be compact. 3.4. What is the difference between the highest and the lowest Female students (as % of total students) of Secondary general education?
Provide a short and direct response. 4.04. What is the difference between the highest and the lowest Female students (as % of total students) of Secondary vocational education?
Offer a very short reply. 6.68. 